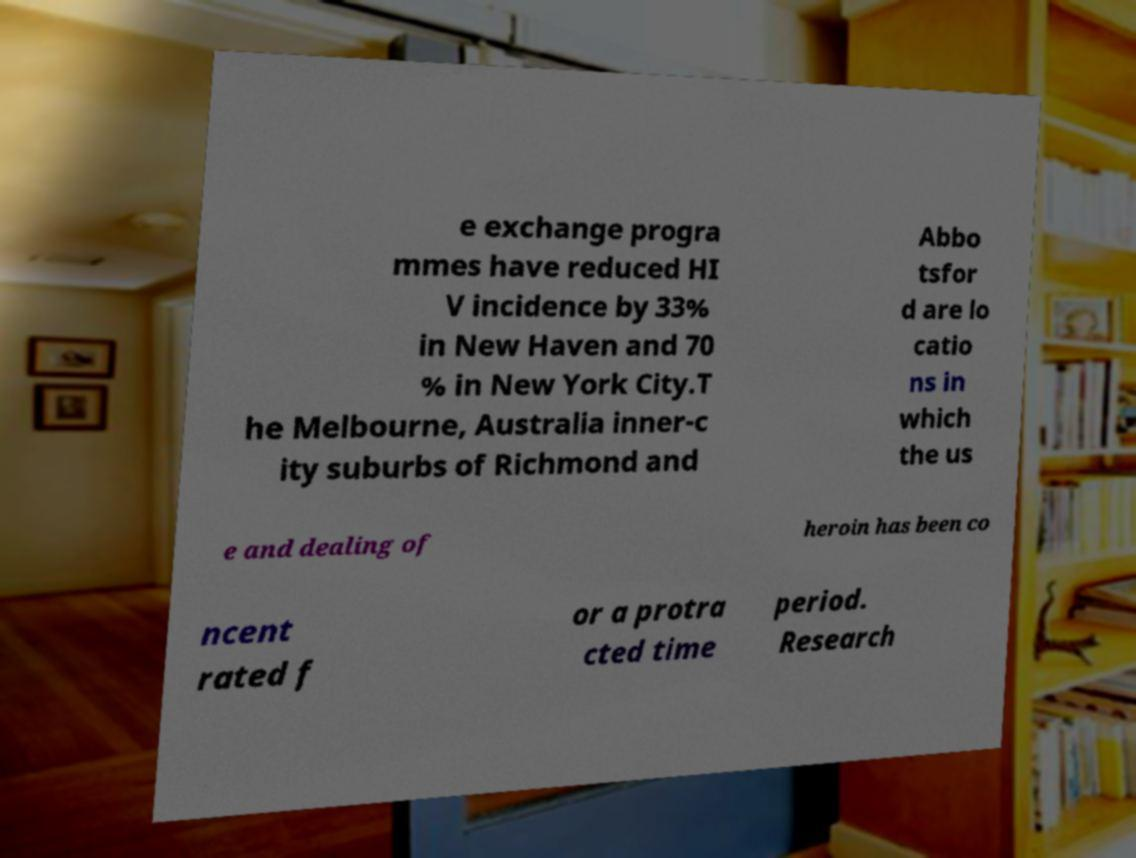I need the written content from this picture converted into text. Can you do that? e exchange progra mmes have reduced HI V incidence by 33% in New Haven and 70 % in New York City.T he Melbourne, Australia inner-c ity suburbs of Richmond and Abbo tsfor d are lo catio ns in which the us e and dealing of heroin has been co ncent rated f or a protra cted time period. Research 